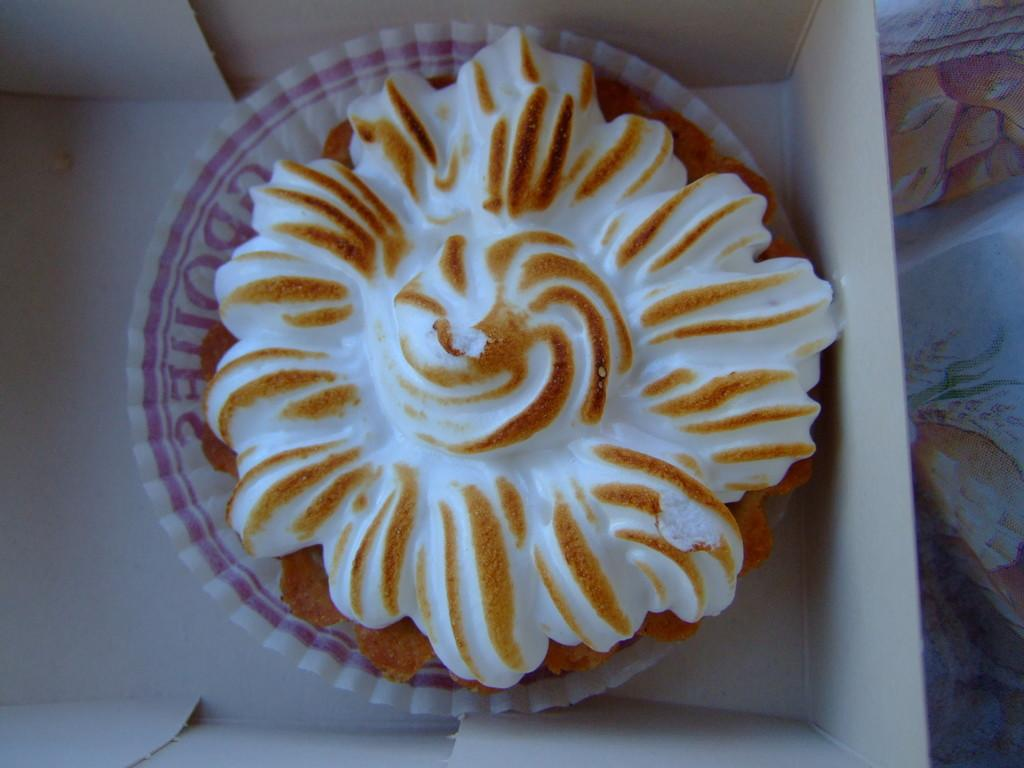What is placed in a box in the image? There is a muffin placed in a box in the image. What can be seen on the right side of the image? There is a cloth on the right side in the image. How many horses are visible in the image? There are no horses visible in the image. What type of hand is shown interacting with the muffin in the image? There is no hand shown interacting with the muffin in the image. 